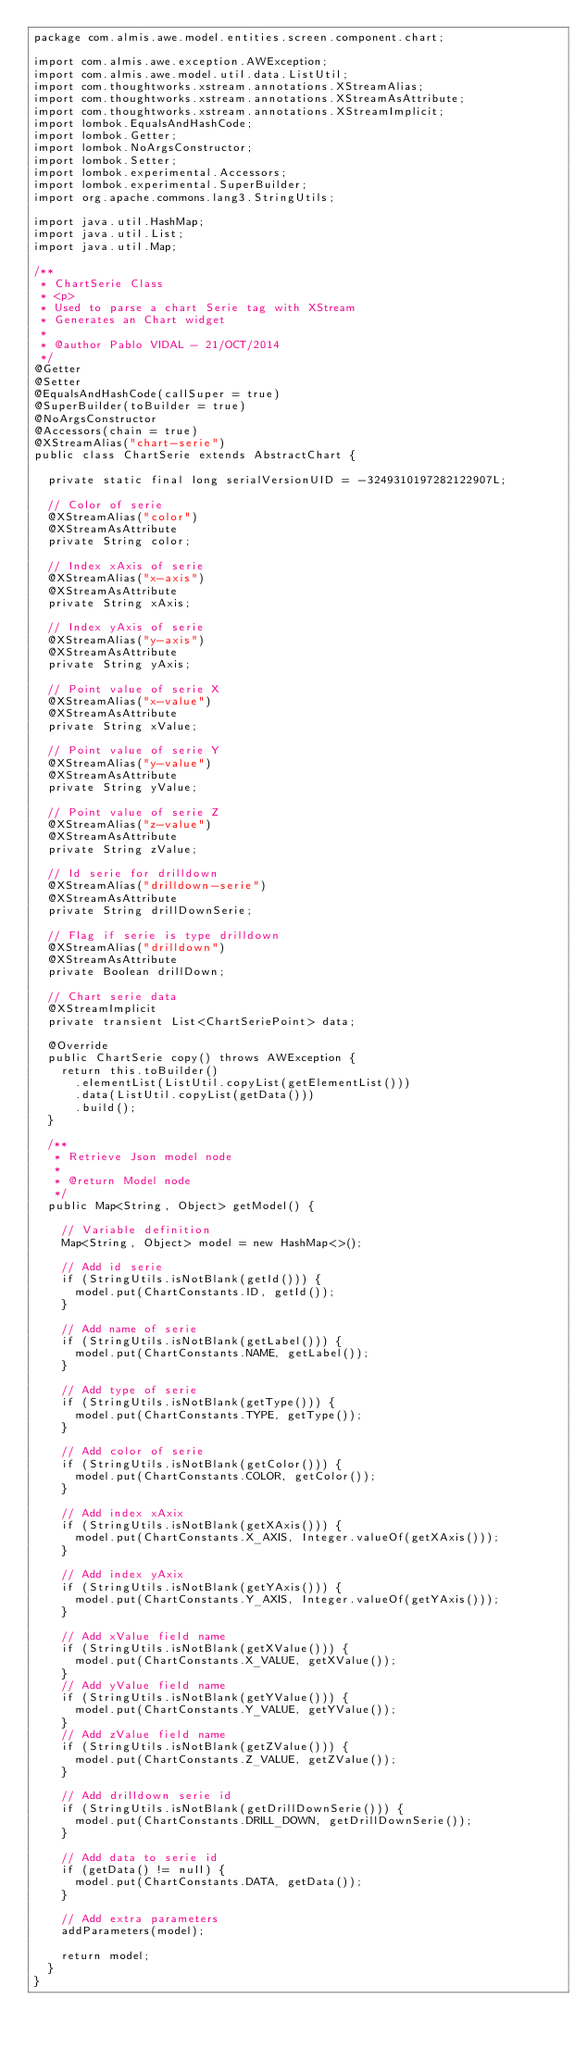<code> <loc_0><loc_0><loc_500><loc_500><_Java_>package com.almis.awe.model.entities.screen.component.chart;

import com.almis.awe.exception.AWException;
import com.almis.awe.model.util.data.ListUtil;
import com.thoughtworks.xstream.annotations.XStreamAlias;
import com.thoughtworks.xstream.annotations.XStreamAsAttribute;
import com.thoughtworks.xstream.annotations.XStreamImplicit;
import lombok.EqualsAndHashCode;
import lombok.Getter;
import lombok.NoArgsConstructor;
import lombok.Setter;
import lombok.experimental.Accessors;
import lombok.experimental.SuperBuilder;
import org.apache.commons.lang3.StringUtils;

import java.util.HashMap;
import java.util.List;
import java.util.Map;

/**
 * ChartSerie Class
 * <p>
 * Used to parse a chart Serie tag with XStream
 * Generates an Chart widget
 *
 * @author Pablo VIDAL - 21/OCT/2014
 */
@Getter
@Setter
@EqualsAndHashCode(callSuper = true)
@SuperBuilder(toBuilder = true)
@NoArgsConstructor
@Accessors(chain = true)
@XStreamAlias("chart-serie")
public class ChartSerie extends AbstractChart {

  private static final long serialVersionUID = -3249310197282122907L;

  // Color of serie
  @XStreamAlias("color")
  @XStreamAsAttribute
  private String color;

  // Index xAxis of serie
  @XStreamAlias("x-axis")
  @XStreamAsAttribute
  private String xAxis;

  // Index yAxis of serie
  @XStreamAlias("y-axis")
  @XStreamAsAttribute
  private String yAxis;

  // Point value of serie X
  @XStreamAlias("x-value")
  @XStreamAsAttribute
  private String xValue;

  // Point value of serie Y
  @XStreamAlias("y-value")
  @XStreamAsAttribute
  private String yValue;

  // Point value of serie Z
  @XStreamAlias("z-value")
  @XStreamAsAttribute
  private String zValue;

  // Id serie for drilldown
  @XStreamAlias("drilldown-serie")
  @XStreamAsAttribute
  private String drillDownSerie;

  // Flag if serie is type drilldown
  @XStreamAlias("drilldown")
  @XStreamAsAttribute
  private Boolean drillDown;

  // Chart serie data
  @XStreamImplicit
  private transient List<ChartSeriePoint> data;

  @Override
  public ChartSerie copy() throws AWException {
    return this.toBuilder()
      .elementList(ListUtil.copyList(getElementList()))
      .data(ListUtil.copyList(getData()))
      .build();
  }

  /**
   * Retrieve Json model node
   *
   * @return Model node
   */
  public Map<String, Object> getModel() {

    // Variable definition
    Map<String, Object> model = new HashMap<>();

    // Add id serie
    if (StringUtils.isNotBlank(getId())) {
      model.put(ChartConstants.ID, getId());
    }

    // Add name of serie
    if (StringUtils.isNotBlank(getLabel())) {
      model.put(ChartConstants.NAME, getLabel());
    }

    // Add type of serie
    if (StringUtils.isNotBlank(getType())) {
      model.put(ChartConstants.TYPE, getType());
    }

    // Add color of serie
    if (StringUtils.isNotBlank(getColor())) {
      model.put(ChartConstants.COLOR, getColor());
    }

    // Add index xAxix
    if (StringUtils.isNotBlank(getXAxis())) {
      model.put(ChartConstants.X_AXIS, Integer.valueOf(getXAxis()));
    }

    // Add index yAxix
    if (StringUtils.isNotBlank(getYAxis())) {
      model.put(ChartConstants.Y_AXIS, Integer.valueOf(getYAxis()));
    }

    // Add xValue field name
    if (StringUtils.isNotBlank(getXValue())) {
      model.put(ChartConstants.X_VALUE, getXValue());
    }
    // Add yValue field name
    if (StringUtils.isNotBlank(getYValue())) {
      model.put(ChartConstants.Y_VALUE, getYValue());
    }
    // Add zValue field name
    if (StringUtils.isNotBlank(getZValue())) {
      model.put(ChartConstants.Z_VALUE, getZValue());
    }

    // Add drilldown serie id
    if (StringUtils.isNotBlank(getDrillDownSerie())) {
      model.put(ChartConstants.DRILL_DOWN, getDrillDownSerie());
    }

    // Add data to serie id
    if (getData() != null) {
      model.put(ChartConstants.DATA, getData());
    }

    // Add extra parameters
    addParameters(model);

    return model;
  }
}
</code> 